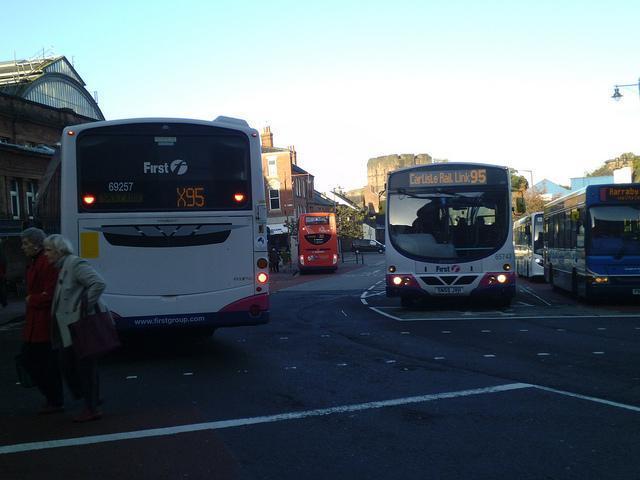How many red buses are there?
Give a very brief answer. 1. How many people are  there?
Give a very brief answer. 2. How many people are there?
Give a very brief answer. 2. How many buses can you see?
Give a very brief answer. 4. 